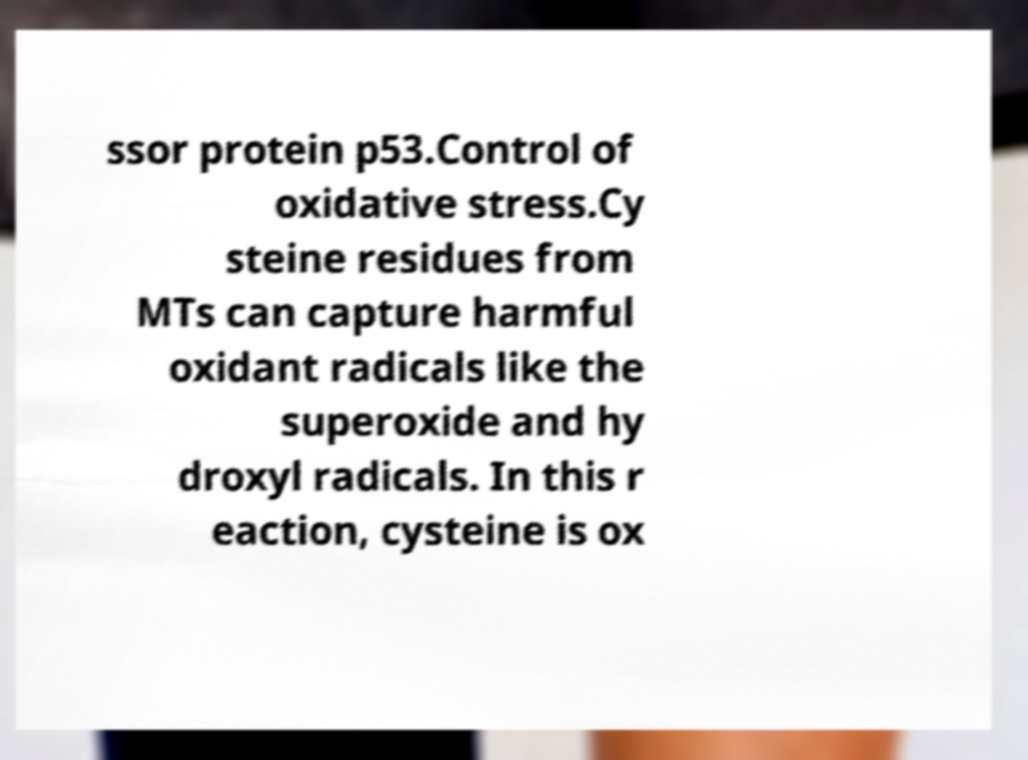There's text embedded in this image that I need extracted. Can you transcribe it verbatim? ssor protein p53.Control of oxidative stress.Cy steine residues from MTs can capture harmful oxidant radicals like the superoxide and hy droxyl radicals. In this r eaction, cysteine is ox 